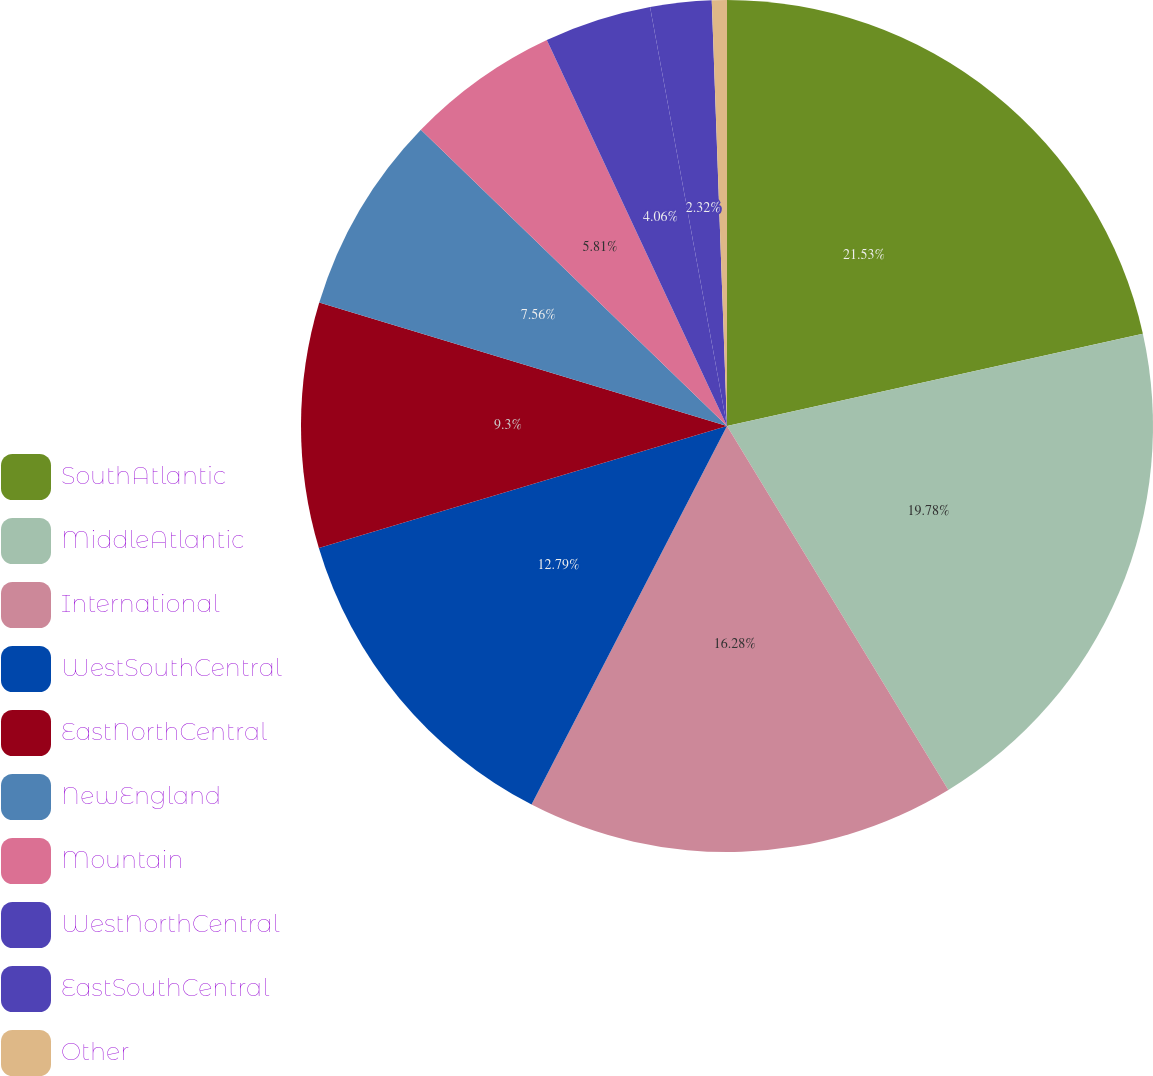Convert chart. <chart><loc_0><loc_0><loc_500><loc_500><pie_chart><fcel>SouthAtlantic<fcel>MiddleAtlantic<fcel>International<fcel>WestSouthCentral<fcel>EastNorthCentral<fcel>NewEngland<fcel>Mountain<fcel>WestNorthCentral<fcel>EastSouthCentral<fcel>Other<nl><fcel>21.52%<fcel>19.78%<fcel>16.28%<fcel>12.79%<fcel>9.3%<fcel>7.56%<fcel>5.81%<fcel>4.06%<fcel>2.32%<fcel>0.57%<nl></chart> 